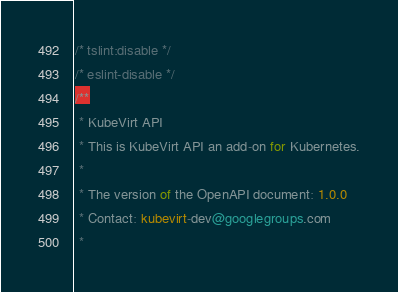Convert code to text. <code><loc_0><loc_0><loc_500><loc_500><_TypeScript_>/* tslint:disable */
/* eslint-disable */
/**
 * KubeVirt API
 * This is KubeVirt API an add-on for Kubernetes.
 *
 * The version of the OpenAPI document: 1.0.0
 * Contact: kubevirt-dev@googlegroups.com
 *</code> 